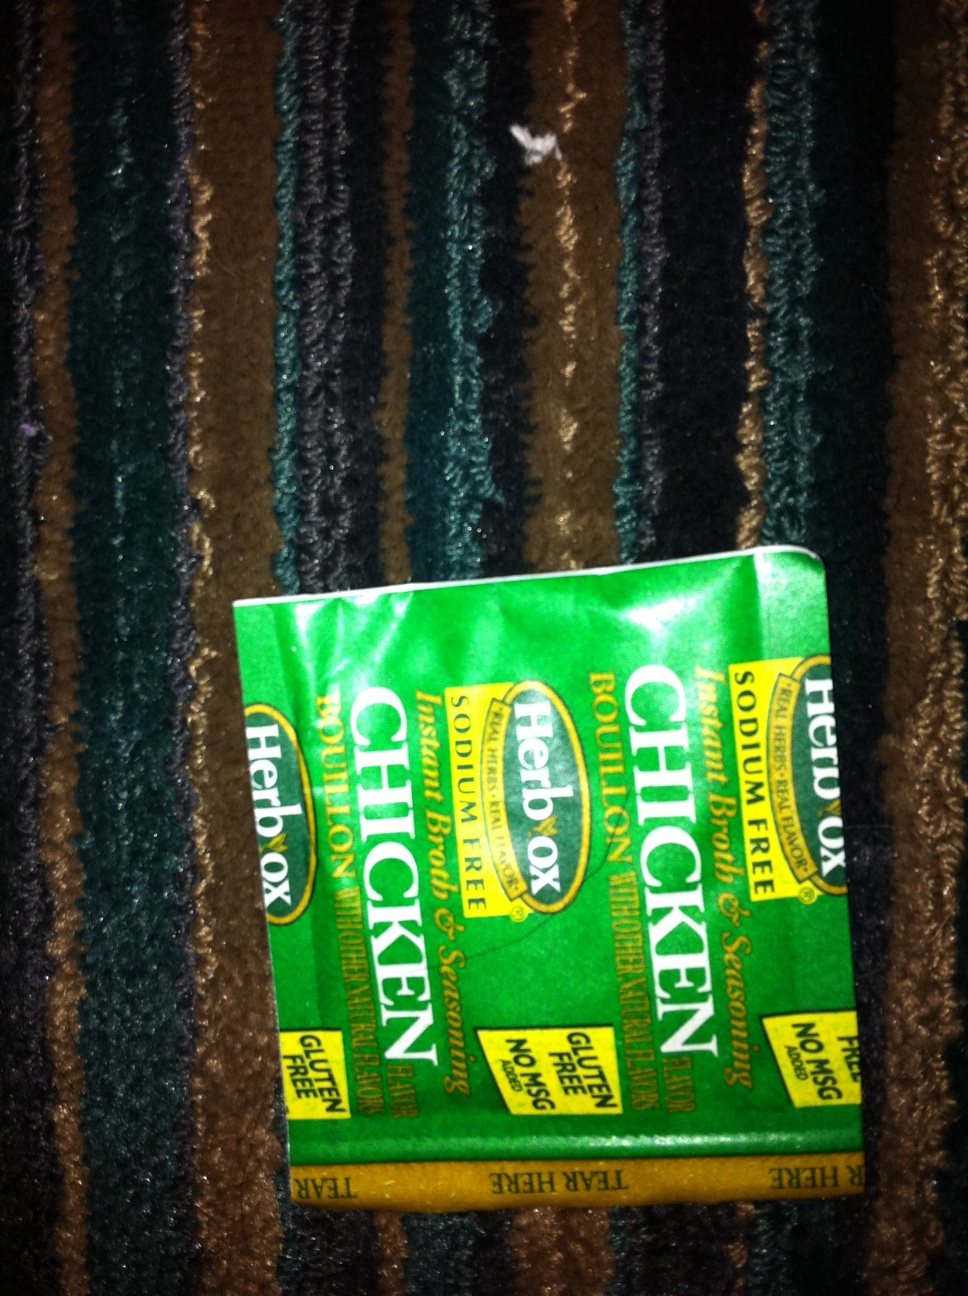What are the instructions for making this bouillon To make this Herbox Chicken Bouillon, dissolve one packet in one cup of boiling water. Stir well until completely dissolved. You can use this as a base for soups, stews, sauces, or to add flavor to your dishes. 